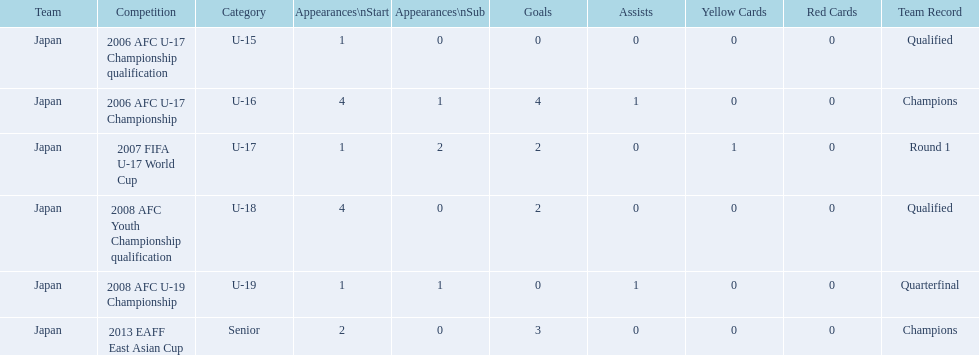In which two competitions did japan lack goals? 2006 AFC U-17 Championship qualification, 2008 AFC U-19 Championship. 